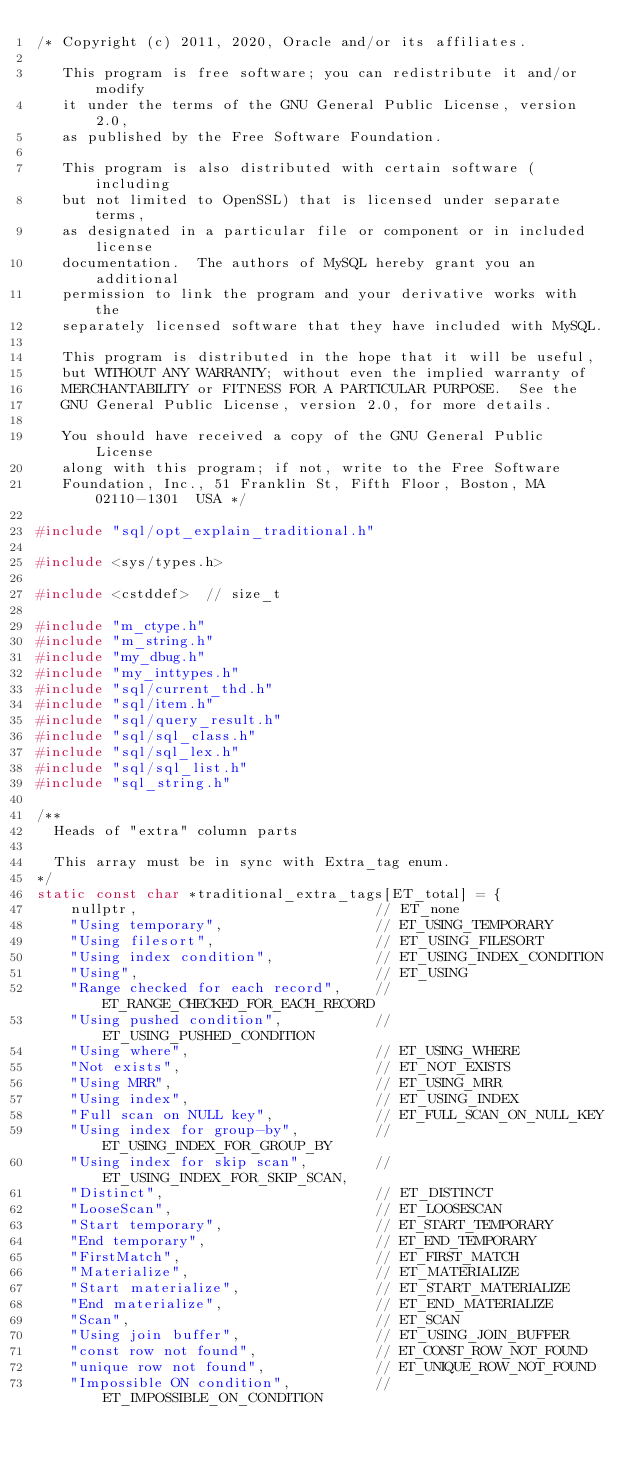<code> <loc_0><loc_0><loc_500><loc_500><_C++_>/* Copyright (c) 2011, 2020, Oracle and/or its affiliates.

   This program is free software; you can redistribute it and/or modify
   it under the terms of the GNU General Public License, version 2.0,
   as published by the Free Software Foundation.

   This program is also distributed with certain software (including
   but not limited to OpenSSL) that is licensed under separate terms,
   as designated in a particular file or component or in included license
   documentation.  The authors of MySQL hereby grant you an additional
   permission to link the program and your derivative works with the
   separately licensed software that they have included with MySQL.

   This program is distributed in the hope that it will be useful,
   but WITHOUT ANY WARRANTY; without even the implied warranty of
   MERCHANTABILITY or FITNESS FOR A PARTICULAR PURPOSE.  See the
   GNU General Public License, version 2.0, for more details.

   You should have received a copy of the GNU General Public License
   along with this program; if not, write to the Free Software
   Foundation, Inc., 51 Franklin St, Fifth Floor, Boston, MA 02110-1301  USA */

#include "sql/opt_explain_traditional.h"

#include <sys/types.h>

#include <cstddef>  // size_t

#include "m_ctype.h"
#include "m_string.h"
#include "my_dbug.h"
#include "my_inttypes.h"
#include "sql/current_thd.h"
#include "sql/item.h"
#include "sql/query_result.h"
#include "sql/sql_class.h"
#include "sql/sql_lex.h"
#include "sql/sql_list.h"
#include "sql_string.h"

/**
  Heads of "extra" column parts

  This array must be in sync with Extra_tag enum.
*/
static const char *traditional_extra_tags[ET_total] = {
    nullptr,                            // ET_none
    "Using temporary",                  // ET_USING_TEMPORARY
    "Using filesort",                   // ET_USING_FILESORT
    "Using index condition",            // ET_USING_INDEX_CONDITION
    "Using",                            // ET_USING
    "Range checked for each record",    // ET_RANGE_CHECKED_FOR_EACH_RECORD
    "Using pushed condition",           // ET_USING_PUSHED_CONDITION
    "Using where",                      // ET_USING_WHERE
    "Not exists",                       // ET_NOT_EXISTS
    "Using MRR",                        // ET_USING_MRR
    "Using index",                      // ET_USING_INDEX
    "Full scan on NULL key",            // ET_FULL_SCAN_ON_NULL_KEY
    "Using index for group-by",         // ET_USING_INDEX_FOR_GROUP_BY
    "Using index for skip scan",        // ET_USING_INDEX_FOR_SKIP_SCAN,
    "Distinct",                         // ET_DISTINCT
    "LooseScan",                        // ET_LOOSESCAN
    "Start temporary",                  // ET_START_TEMPORARY
    "End temporary",                    // ET_END_TEMPORARY
    "FirstMatch",                       // ET_FIRST_MATCH
    "Materialize",                      // ET_MATERIALIZE
    "Start materialize",                // ET_START_MATERIALIZE
    "End materialize",                  // ET_END_MATERIALIZE
    "Scan",                             // ET_SCAN
    "Using join buffer",                // ET_USING_JOIN_BUFFER
    "const row not found",              // ET_CONST_ROW_NOT_FOUND
    "unique row not found",             // ET_UNIQUE_ROW_NOT_FOUND
    "Impossible ON condition",          // ET_IMPOSSIBLE_ON_CONDITION</code> 